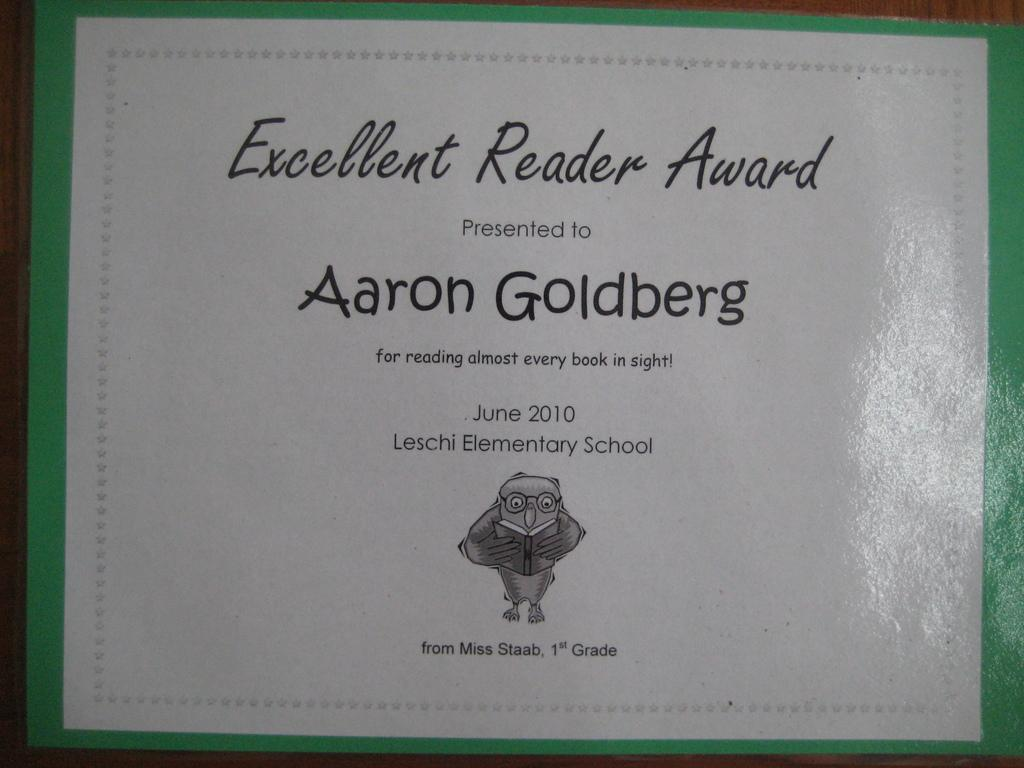What is present in the image that contains information? There is a paper in the image that contains text. What is depicted on the paper? There is a picture of a bird holding a book on the paper. What type of object is at the bottom of the image? There is a wooden object at the bottom of the image. What type of harmony can be heard in the background of the image? There is no audible harmony in the image, as it is a still image containing a paper, text, and a picture of a bird holding a book. 